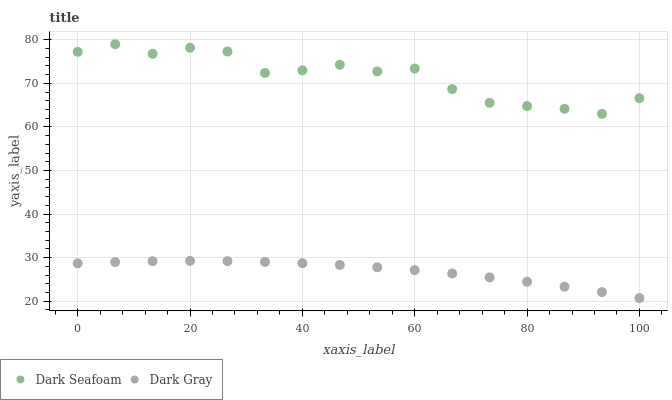Does Dark Gray have the minimum area under the curve?
Answer yes or no. Yes. Does Dark Seafoam have the maximum area under the curve?
Answer yes or no. Yes. Does Dark Seafoam have the minimum area under the curve?
Answer yes or no. No. Is Dark Gray the smoothest?
Answer yes or no. Yes. Is Dark Seafoam the roughest?
Answer yes or no. Yes. Is Dark Seafoam the smoothest?
Answer yes or no. No. Does Dark Gray have the lowest value?
Answer yes or no. Yes. Does Dark Seafoam have the lowest value?
Answer yes or no. No. Does Dark Seafoam have the highest value?
Answer yes or no. Yes. Is Dark Gray less than Dark Seafoam?
Answer yes or no. Yes. Is Dark Seafoam greater than Dark Gray?
Answer yes or no. Yes. Does Dark Gray intersect Dark Seafoam?
Answer yes or no. No. 